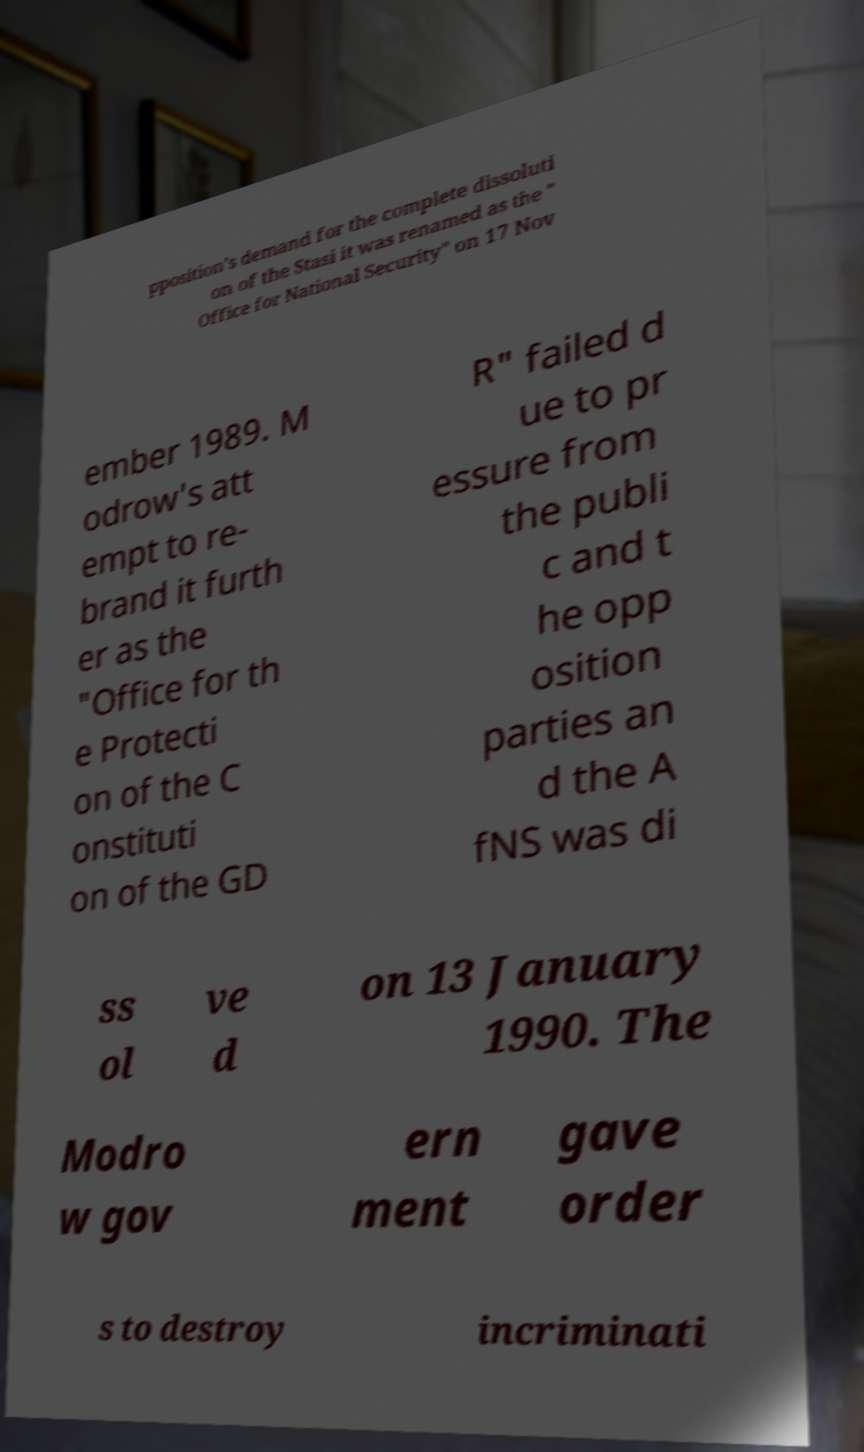Could you assist in decoding the text presented in this image and type it out clearly? pposition's demand for the complete dissoluti on of the Stasi it was renamed as the " Office for National Security" on 17 Nov ember 1989. M odrow's att empt to re- brand it furth er as the "Office for th e Protecti on of the C onstituti on of the GD R" failed d ue to pr essure from the publi c and t he opp osition parties an d the A fNS was di ss ol ve d on 13 January 1990. The Modro w gov ern ment gave order s to destroy incriminati 